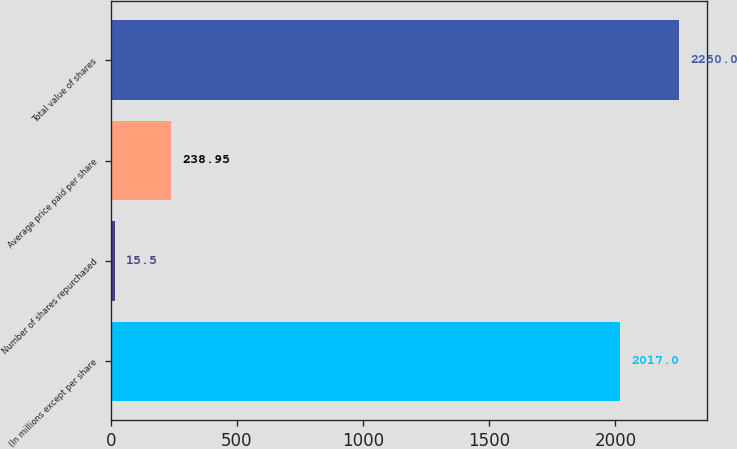<chart> <loc_0><loc_0><loc_500><loc_500><bar_chart><fcel>(In millions except per share<fcel>Number of shares repurchased<fcel>Average price paid per share<fcel>Total value of shares<nl><fcel>2017<fcel>15.5<fcel>238.95<fcel>2250<nl></chart> 